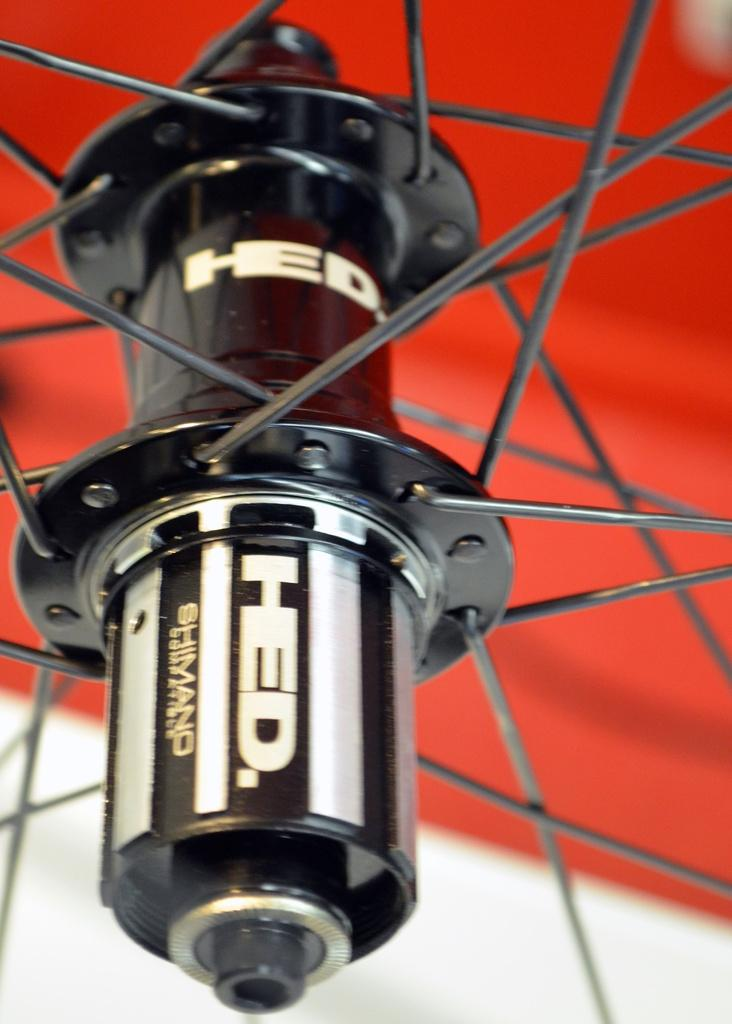What is the main subject of the image? The main subject of the image is a bicycle wheel. What is the color scheme of the bicycle wheel? The bicycle wheel is in black and white color. What colors are present in the background of the image? The background of the image is white and red in color. How many birds can be seen flying over the town in the image? There are no birds or towns present in the image; it features a black and white bicycle wheel against a white and red background. 